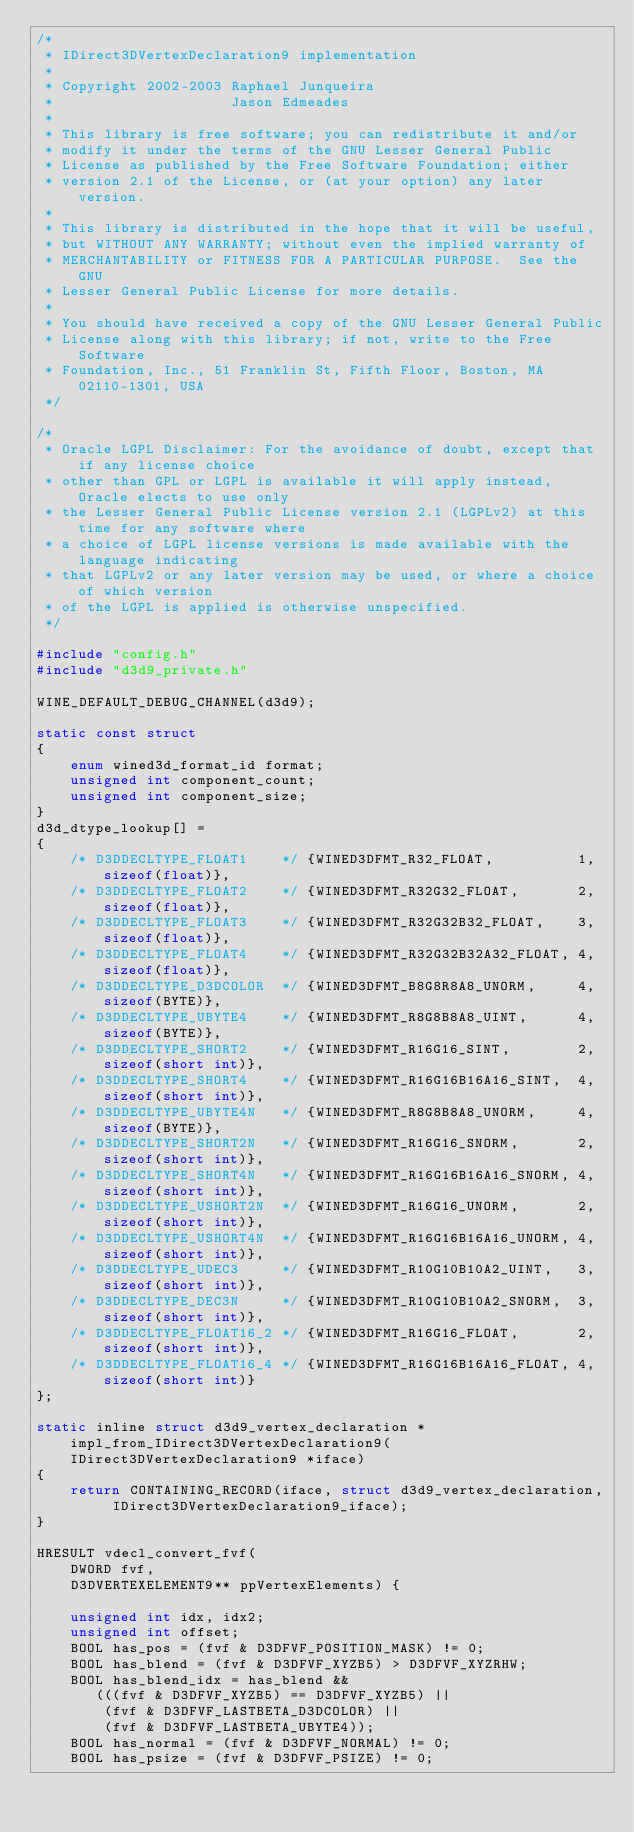Convert code to text. <code><loc_0><loc_0><loc_500><loc_500><_C_>/*
 * IDirect3DVertexDeclaration9 implementation
 *
 * Copyright 2002-2003 Raphael Junqueira
 *                     Jason Edmeades
 *
 * This library is free software; you can redistribute it and/or
 * modify it under the terms of the GNU Lesser General Public
 * License as published by the Free Software Foundation; either
 * version 2.1 of the License, or (at your option) any later version.
 *
 * This library is distributed in the hope that it will be useful,
 * but WITHOUT ANY WARRANTY; without even the implied warranty of
 * MERCHANTABILITY or FITNESS FOR A PARTICULAR PURPOSE.  See the GNU
 * Lesser General Public License for more details.
 *
 * You should have received a copy of the GNU Lesser General Public
 * License along with this library; if not, write to the Free Software
 * Foundation, Inc., 51 Franklin St, Fifth Floor, Boston, MA 02110-1301, USA
 */

/*
 * Oracle LGPL Disclaimer: For the avoidance of doubt, except that if any license choice
 * other than GPL or LGPL is available it will apply instead, Oracle elects to use only
 * the Lesser General Public License version 2.1 (LGPLv2) at this time for any software where
 * a choice of LGPL license versions is made available with the language indicating
 * that LGPLv2 or any later version may be used, or where a choice of which version
 * of the LGPL is applied is otherwise unspecified.
 */

#include "config.h"
#include "d3d9_private.h"

WINE_DEFAULT_DEBUG_CHANNEL(d3d9);

static const struct
{
    enum wined3d_format_id format;
    unsigned int component_count;
    unsigned int component_size;
}
d3d_dtype_lookup[] =
{
    /* D3DDECLTYPE_FLOAT1    */ {WINED3DFMT_R32_FLOAT,          1, sizeof(float)},
    /* D3DDECLTYPE_FLOAT2    */ {WINED3DFMT_R32G32_FLOAT,       2, sizeof(float)},
    /* D3DDECLTYPE_FLOAT3    */ {WINED3DFMT_R32G32B32_FLOAT,    3, sizeof(float)},
    /* D3DDECLTYPE_FLOAT4    */ {WINED3DFMT_R32G32B32A32_FLOAT, 4, sizeof(float)},
    /* D3DDECLTYPE_D3DCOLOR  */ {WINED3DFMT_B8G8R8A8_UNORM,     4, sizeof(BYTE)},
    /* D3DDECLTYPE_UBYTE4    */ {WINED3DFMT_R8G8B8A8_UINT,      4, sizeof(BYTE)},
    /* D3DDECLTYPE_SHORT2    */ {WINED3DFMT_R16G16_SINT,        2, sizeof(short int)},
    /* D3DDECLTYPE_SHORT4    */ {WINED3DFMT_R16G16B16A16_SINT,  4, sizeof(short int)},
    /* D3DDECLTYPE_UBYTE4N   */ {WINED3DFMT_R8G8B8A8_UNORM,     4, sizeof(BYTE)},
    /* D3DDECLTYPE_SHORT2N   */ {WINED3DFMT_R16G16_SNORM,       2, sizeof(short int)},
    /* D3DDECLTYPE_SHORT4N   */ {WINED3DFMT_R16G16B16A16_SNORM, 4, sizeof(short int)},
    /* D3DDECLTYPE_USHORT2N  */ {WINED3DFMT_R16G16_UNORM,       2, sizeof(short int)},
    /* D3DDECLTYPE_USHORT4N  */ {WINED3DFMT_R16G16B16A16_UNORM, 4, sizeof(short int)},
    /* D3DDECLTYPE_UDEC3     */ {WINED3DFMT_R10G10B10A2_UINT,   3, sizeof(short int)},
    /* D3DDECLTYPE_DEC3N     */ {WINED3DFMT_R10G10B10A2_SNORM,  3, sizeof(short int)},
    /* D3DDECLTYPE_FLOAT16_2 */ {WINED3DFMT_R16G16_FLOAT,       2, sizeof(short int)},
    /* D3DDECLTYPE_FLOAT16_4 */ {WINED3DFMT_R16G16B16A16_FLOAT, 4, sizeof(short int)}
};

static inline struct d3d9_vertex_declaration *impl_from_IDirect3DVertexDeclaration9(IDirect3DVertexDeclaration9 *iface)
{
    return CONTAINING_RECORD(iface, struct d3d9_vertex_declaration, IDirect3DVertexDeclaration9_iface);
}

HRESULT vdecl_convert_fvf(
    DWORD fvf,
    D3DVERTEXELEMENT9** ppVertexElements) {

    unsigned int idx, idx2;
    unsigned int offset;
    BOOL has_pos = (fvf & D3DFVF_POSITION_MASK) != 0;
    BOOL has_blend = (fvf & D3DFVF_XYZB5) > D3DFVF_XYZRHW;
    BOOL has_blend_idx = has_blend &&
       (((fvf & D3DFVF_XYZB5) == D3DFVF_XYZB5) ||
        (fvf & D3DFVF_LASTBETA_D3DCOLOR) ||
        (fvf & D3DFVF_LASTBETA_UBYTE4));
    BOOL has_normal = (fvf & D3DFVF_NORMAL) != 0;
    BOOL has_psize = (fvf & D3DFVF_PSIZE) != 0;
</code> 